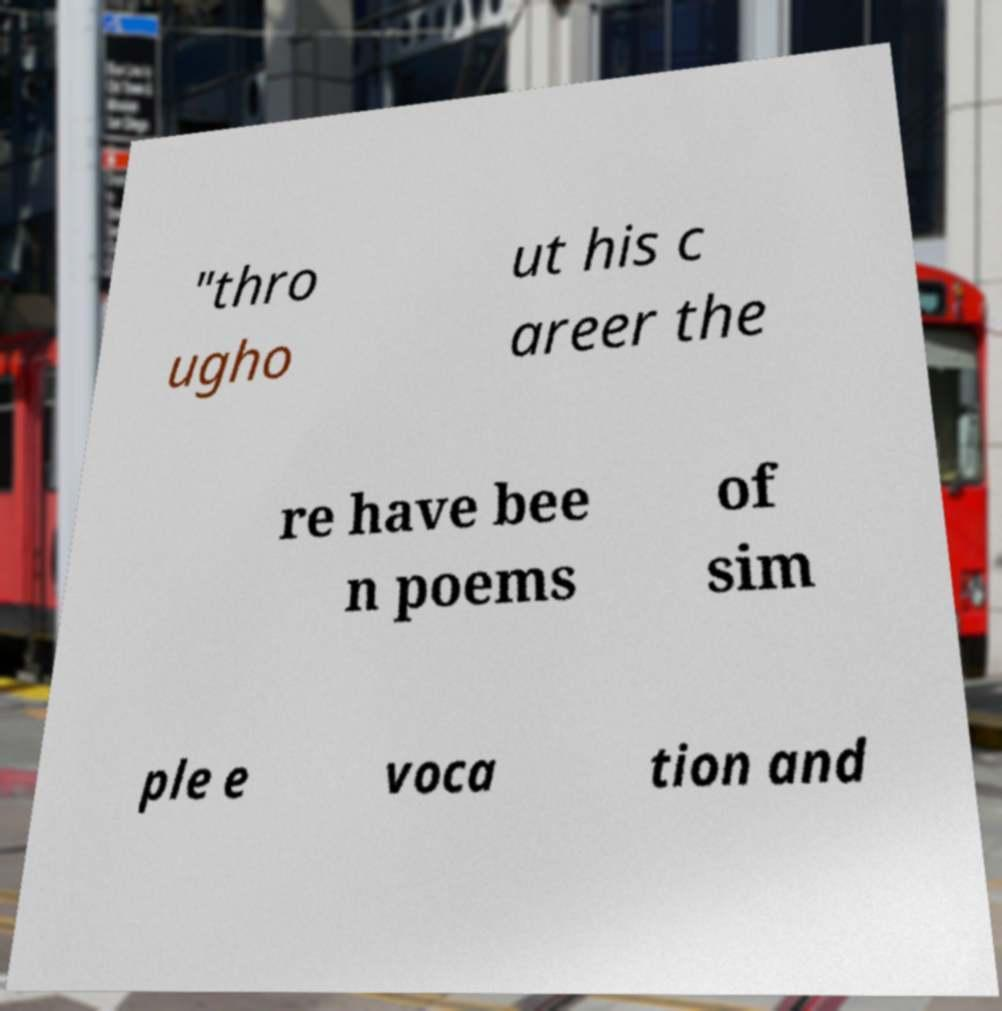Can you read and provide the text displayed in the image?This photo seems to have some interesting text. Can you extract and type it out for me? "thro ugho ut his c areer the re have bee n poems of sim ple e voca tion and 